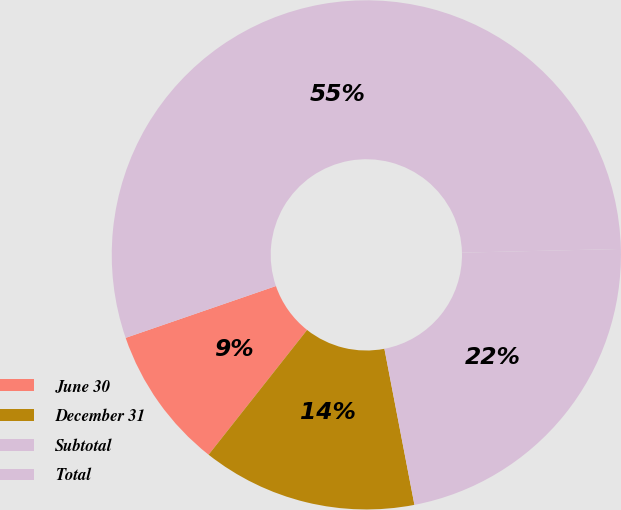<chart> <loc_0><loc_0><loc_500><loc_500><pie_chart><fcel>June 30<fcel>December 31<fcel>Subtotal<fcel>Total<nl><fcel>9.08%<fcel>13.66%<fcel>22.34%<fcel>54.91%<nl></chart> 